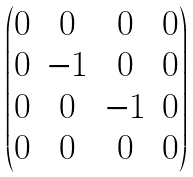<formula> <loc_0><loc_0><loc_500><loc_500>\begin{pmatrix} 0 & 0 & 0 & 0 \\ 0 & - 1 & 0 & 0 \\ 0 & 0 & - 1 & 0 \\ 0 & 0 & 0 & 0 \end{pmatrix}</formula> 